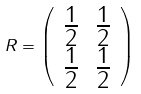Convert formula to latex. <formula><loc_0><loc_0><loc_500><loc_500>R = \left ( \begin{array} { c c } \frac { 1 } { 2 } & \frac { 1 } { 2 } \\ \frac { 1 } { 2 } & \frac { 1 } { 2 } \end{array} \right )</formula> 